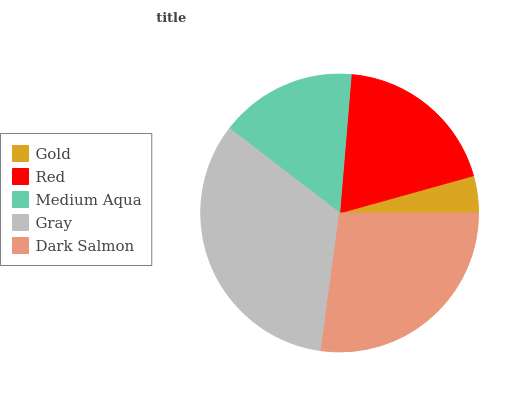Is Gold the minimum?
Answer yes or no. Yes. Is Gray the maximum?
Answer yes or no. Yes. Is Red the minimum?
Answer yes or no. No. Is Red the maximum?
Answer yes or no. No. Is Red greater than Gold?
Answer yes or no. Yes. Is Gold less than Red?
Answer yes or no. Yes. Is Gold greater than Red?
Answer yes or no. No. Is Red less than Gold?
Answer yes or no. No. Is Red the high median?
Answer yes or no. Yes. Is Red the low median?
Answer yes or no. Yes. Is Dark Salmon the high median?
Answer yes or no. No. Is Gold the low median?
Answer yes or no. No. 